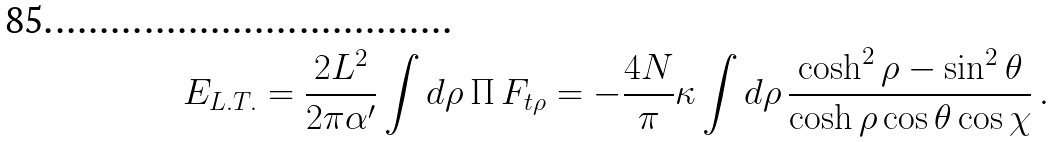<formula> <loc_0><loc_0><loc_500><loc_500>E _ { L . T . } = \frac { 2 L ^ { 2 } } { 2 \pi \alpha ^ { \prime } } \int d \rho \, \Pi \, F _ { t \rho } = - \frac { 4 N } { \pi } \kappa \int d \rho \, \frac { \cosh ^ { 2 } \rho - \sin ^ { 2 } \theta } { \cosh \rho \cos \theta \cos \chi } \, .</formula> 